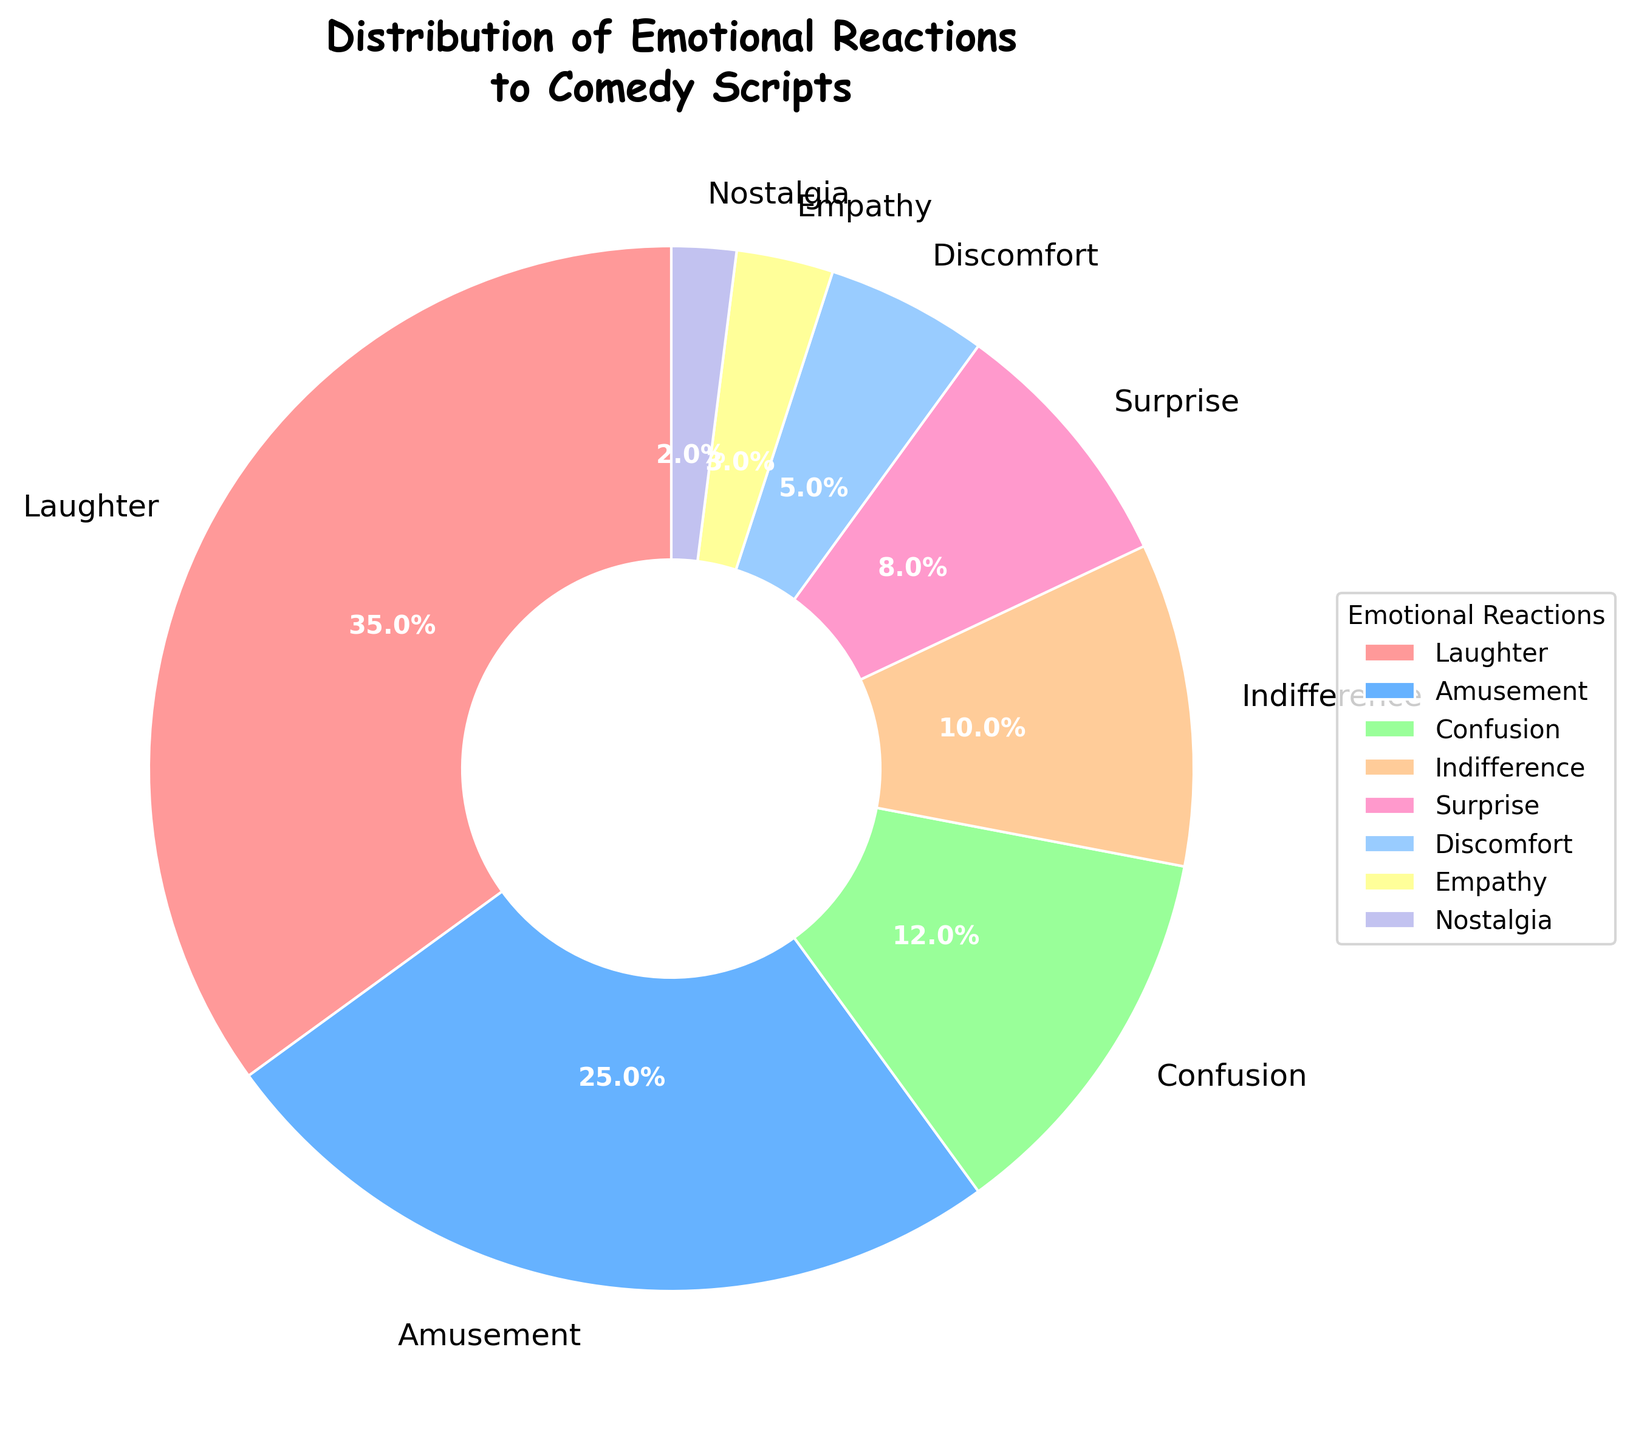what is the total percentage of positive reactions (like laughter, amusement, and surprise)? To find the total percentage of positive reactions, you need to sum up the percentages for laughter, amusement, and surprise. Specifically, add 35 (laughter), 25 (amusement), and 8 (surprise). This sum gives you the total percentage of positive reactions.
Answer: 68 which emotional reaction had the highest percentage? The pie chart displays the percentages of various emotional reactions. By observing the largest segment, it is evident that laughter had the highest percentage.
Answer: Laughter how much more common was indifference compared to nostalgia? To determine the difference in percentages, subtract the percentage of nostalgia from the percentage of indifference. Specifically, 10 (indifference) - 2 (nostalgia) = 8. So, indifference was 8% more common than nostalgia.
Answer: 8 what percentage of reactions were either confusion or discomfort? Add the percentages of confusion and discomfort to find the total percentage for these reactions. That is, 12 (confusion) + 5 (discomfort) = 17.
Answer: 17 which reaction occupies the smallest segment? By observing the smallest segment in the pie chart, it is clear that nostalgia occupies the smallest segment among all the emotional reactions.
Answer: Nostalgia is amusement more common than indifference? Compare the percentages of amusement and indifference. Amusement is 25% and indifference is 10%. Since 25% is greater than 10%, amusement is more common than indifference.
Answer: Yes what is the combined percentage of empathy and nostalgia? To find the combined percentage of empathy and nostalgia, sum their individual percentages: 3 (empathy) + 2 (nostalgia) = 5.
Answer: 5 how does the percentage of amusement compare to that of surprise? Compare the percentage values of amusement and surprise. Amusement has a percentage of 25%, while surprise is at 8%. Therefore, amusement is more common than surprise.
Answer: Amusement is more common how much higher is the percentage of laughter compared to discomfort? Subtract the percentage of discomfort from that of laughter to find the difference: 35 (laughter) - 5 (discomfort) = 30.
Answer: 30 what’s the total percentage of reactions classified as either positive or neutral? (Positive: laughter, amusement, surprise; Neutral: indifference) Add the percentages for laughter, amusement, surprise, and indifference: 35 (laughter) + 25 (amusement) + 8 (surprise) + 10 (indifference) = 78.
Answer: 78 